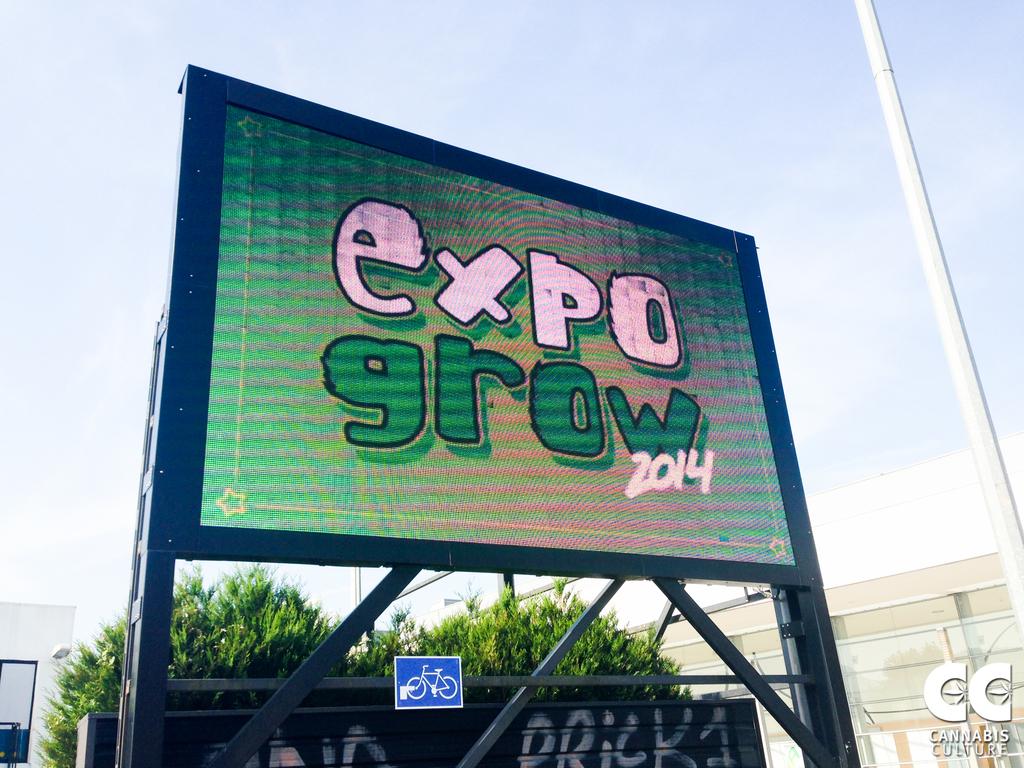What event is it?
Provide a succinct answer. Expo grow 2014. What does the graffiti say on the bottom?
Give a very brief answer. Prick1. 